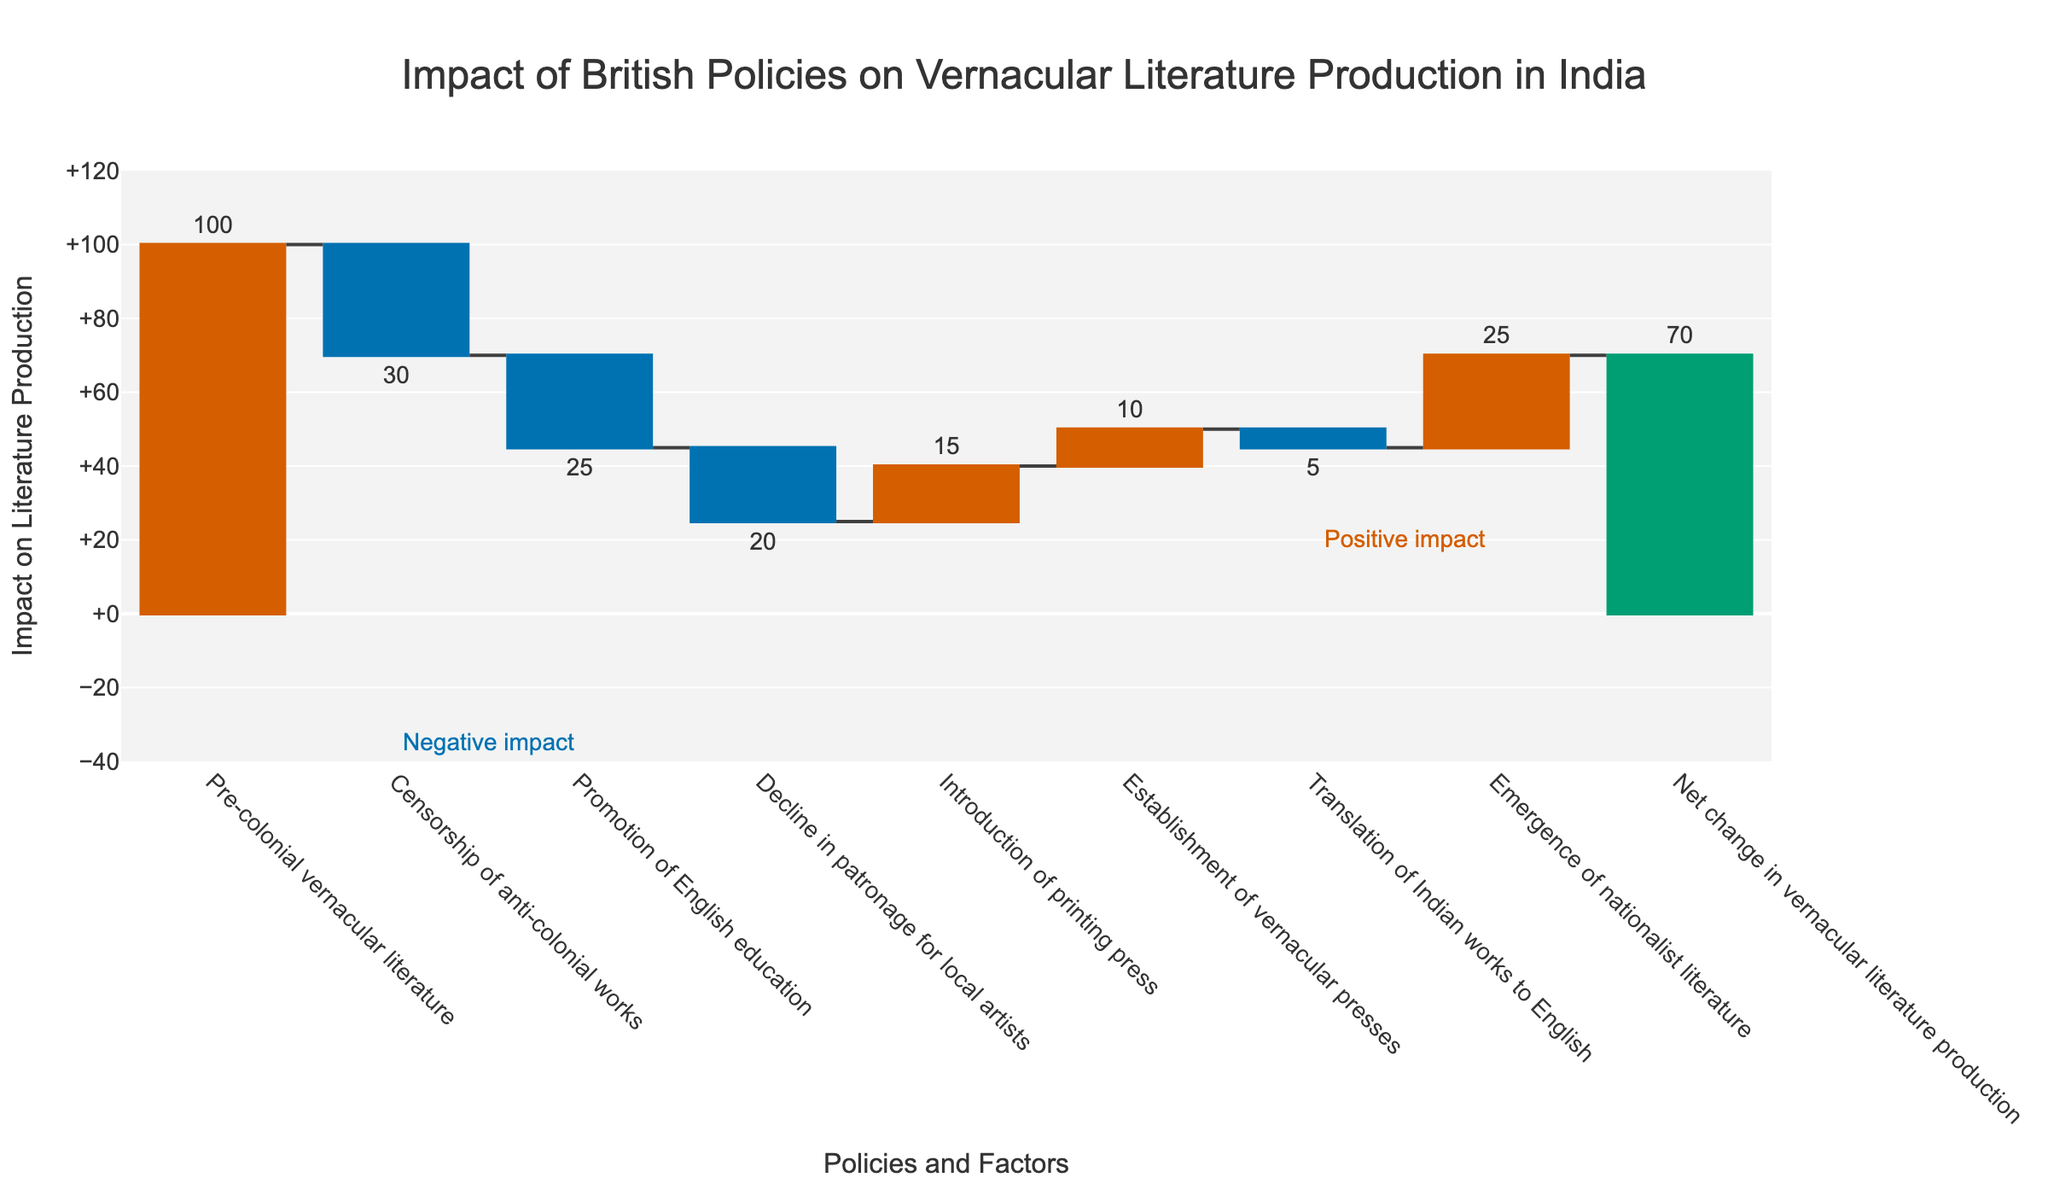What is the title of the Waterfall Chart? The title is typically found at the top-center of the chart and it describes the overall purpose or theme of the visualization.
Answer: Impact of British Policies on Vernacular Literature Production in India What is the total net change in vernacular literature production? The total net change is displayed in the last bar of the waterfall chart, which represents the cumulative effect of all the previous categories.
Answer: 70 Which category had the largest negative impact on vernacular literature production? By comparing the lengths of the blue (decreasing) bars, the longest/most negative bar represents the largest negative impact.
Answer: Censorship of anti-colonial works How much did the promotion of English education affect vernacular literature production? Locate the bar labeled "Promotion of English education" and refer to the value associated with it.
Answer: -25 Which category had the highest positive impact on vernacular literature production? By comparing the lengths of the red (increasing) bars, the longest/most positive bar represents the highest positive impact.
Answer: Emergence of nationalist literature What is the difference in impact between the promotion of English education and the introduction of the printing press? Subtract the impact value of "Promotion of English education" from the impact value of "Introduction of printing press": -25 - 15.
Answer: -40 How many categories resulted in a decrease in vernacular literature production? Count the number of blue (decreasing) bars in the chart.
Answer: 4 Which two categories combined had the smallest absolute impact on vernacular literature production? By identifying the two shortest bars regardless of color (which have the smallest absolute values): "Translation of Indian works to English" and "Establishment of vernacular presses" and then checking their values.
Answer: Translation of Indian works to English and Establishment of vernacular presses What is the net impact of all categories before the introduction of the printing press? Sum the impact values of all categories before "Introduction of printing press": 100 + (-30) + (-25) + (-20).
Answer: 25 Which categories show a positive effect on vernacular literature production? Identify the categories associated with red (increasing) bars, which denote positive impacts.
Answer: Introduction of printing press, Establishment of vernacular presses, Emergence of nationalist literature 